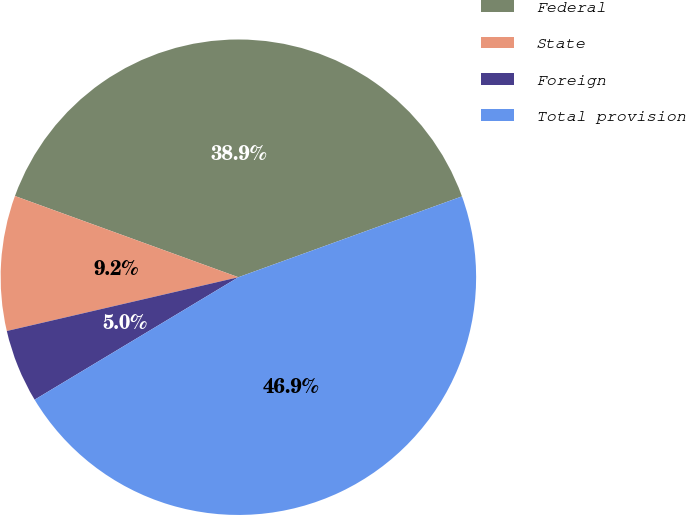<chart> <loc_0><loc_0><loc_500><loc_500><pie_chart><fcel>Federal<fcel>State<fcel>Foreign<fcel>Total provision<nl><fcel>38.93%<fcel>9.18%<fcel>4.98%<fcel>46.91%<nl></chart> 